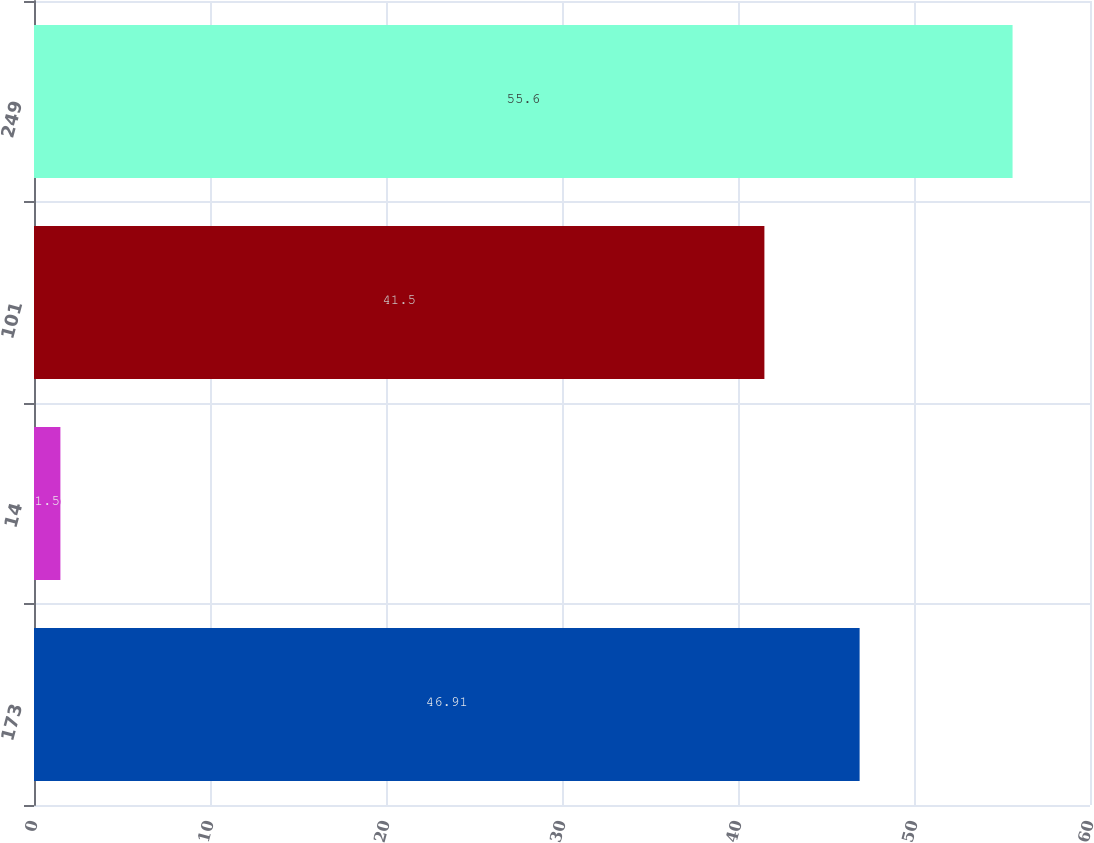Convert chart to OTSL. <chart><loc_0><loc_0><loc_500><loc_500><bar_chart><fcel>173<fcel>14<fcel>101<fcel>249<nl><fcel>46.91<fcel>1.5<fcel>41.5<fcel>55.6<nl></chart> 